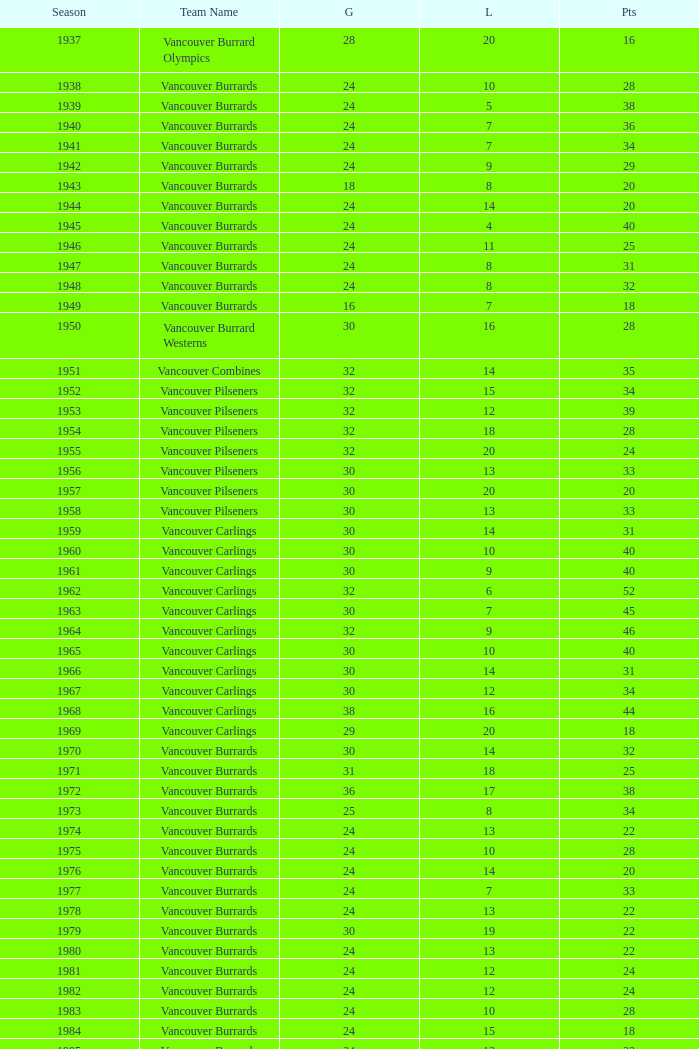What's the total number of points when the vancouver carlings have fewer than 12 losses and more than 32 games? 0.0. 